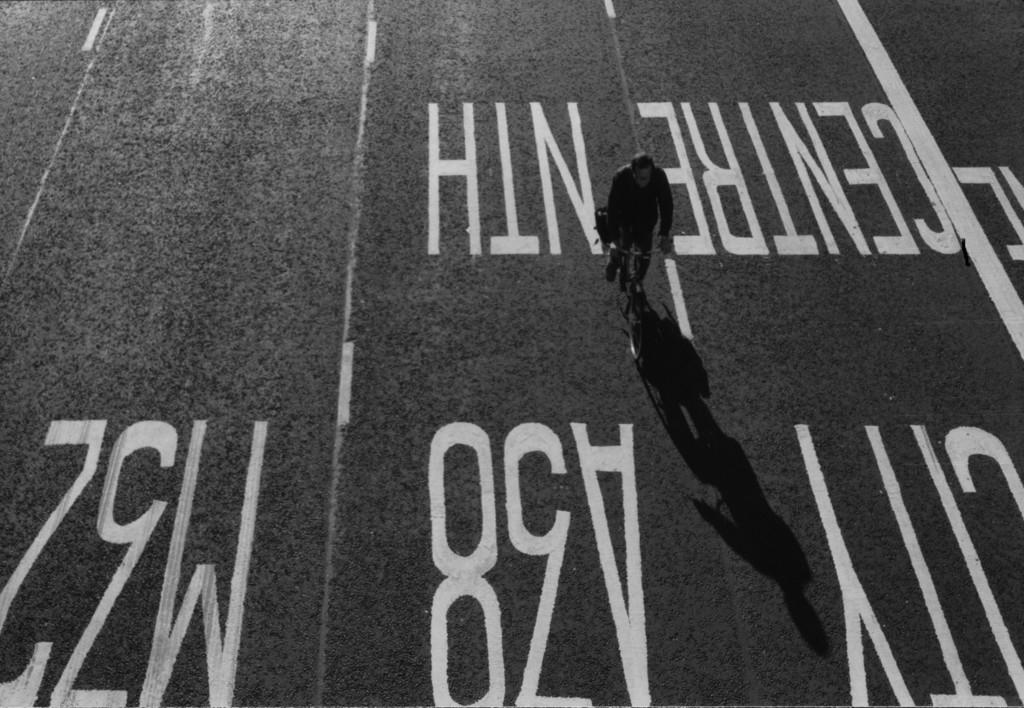What is the main subject of the image? The main subject of the image is a person riding a bicycle on the road. Can you describe any additional details about the bicycle? Yes, there is something written in white color on the bicycle. Can you see the person's brother riding a rifle in the image? There is no brother or rifle present in the image; it only features a person riding a bicycle with something written in white color. 